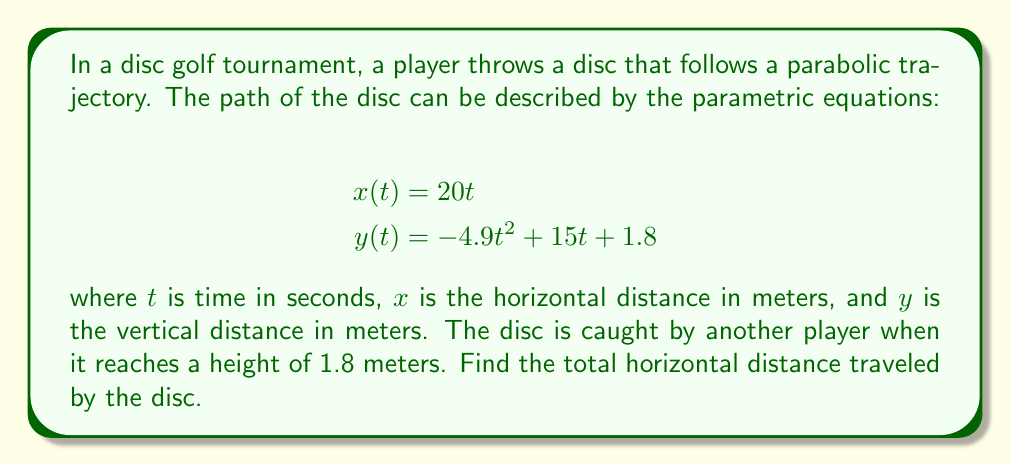What is the answer to this math problem? To solve this problem, we'll follow these steps:

1) The disc is caught when it reaches a height of 1.8 meters. This means we need to find the time $t$ when $y(t) = 1.8$.

2) Set up the equation:
   $$1.8 = -4.9t^2 + 15t + 1.8$$

3) Simplify:
   $$0 = -4.9t^2 + 15t$$

4) Factor out $t$:
   $$0 = t(-4.9t + 15)$$

5) Solve for $t$:
   $$t = 0$$ or $$-4.9t + 15 = 0$$
   $$t = 0$$ or $$t = \frac{15}{4.9} \approx 3.06$$

6) We discard the $t = 0$ solution as it represents the starting point. The disc is caught at $t \approx 3.06$ seconds.

7) To find the horizontal distance, we substitute this time into the $x(t)$ equation:
   $$x(3.06) = 20 * 3.06 = 61.2$$

Therefore, the total horizontal distance traveled by the disc is approximately 61.2 meters.
Answer: 61.2 meters 